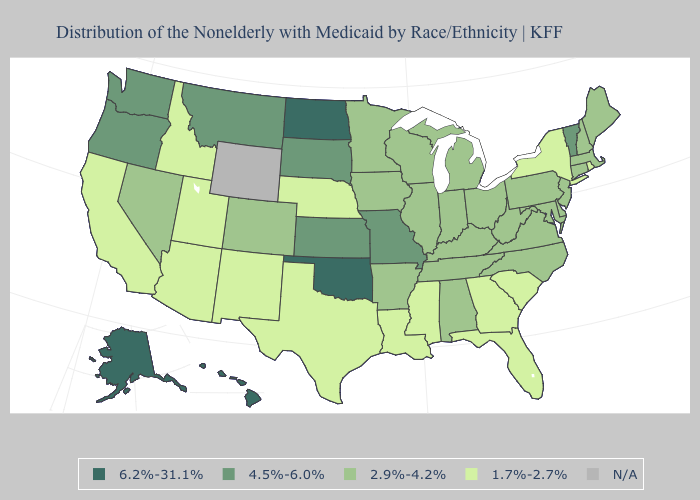What is the highest value in the USA?
Give a very brief answer. 6.2%-31.1%. Name the states that have a value in the range 2.9%-4.2%?
Write a very short answer. Alabama, Arkansas, Colorado, Connecticut, Delaware, Illinois, Indiana, Iowa, Kentucky, Maine, Maryland, Massachusetts, Michigan, Minnesota, Nevada, New Hampshire, New Jersey, North Carolina, Ohio, Pennsylvania, Tennessee, Virginia, West Virginia, Wisconsin. What is the highest value in the West ?
Write a very short answer. 6.2%-31.1%. Among the states that border New Mexico , does Texas have the highest value?
Concise answer only. No. Does Hawaii have the highest value in the USA?
Answer briefly. Yes. Does the map have missing data?
Quick response, please. Yes. What is the value of Indiana?
Quick response, please. 2.9%-4.2%. Which states hav the highest value in the West?
Short answer required. Alaska, Hawaii. What is the value of Utah?
Concise answer only. 1.7%-2.7%. Name the states that have a value in the range 6.2%-31.1%?
Keep it brief. Alaska, Hawaii, North Dakota, Oklahoma. Name the states that have a value in the range N/A?
Concise answer only. Wyoming. What is the lowest value in the West?
Keep it brief. 1.7%-2.7%. Is the legend a continuous bar?
Give a very brief answer. No. What is the value of New York?
Be succinct. 1.7%-2.7%. 